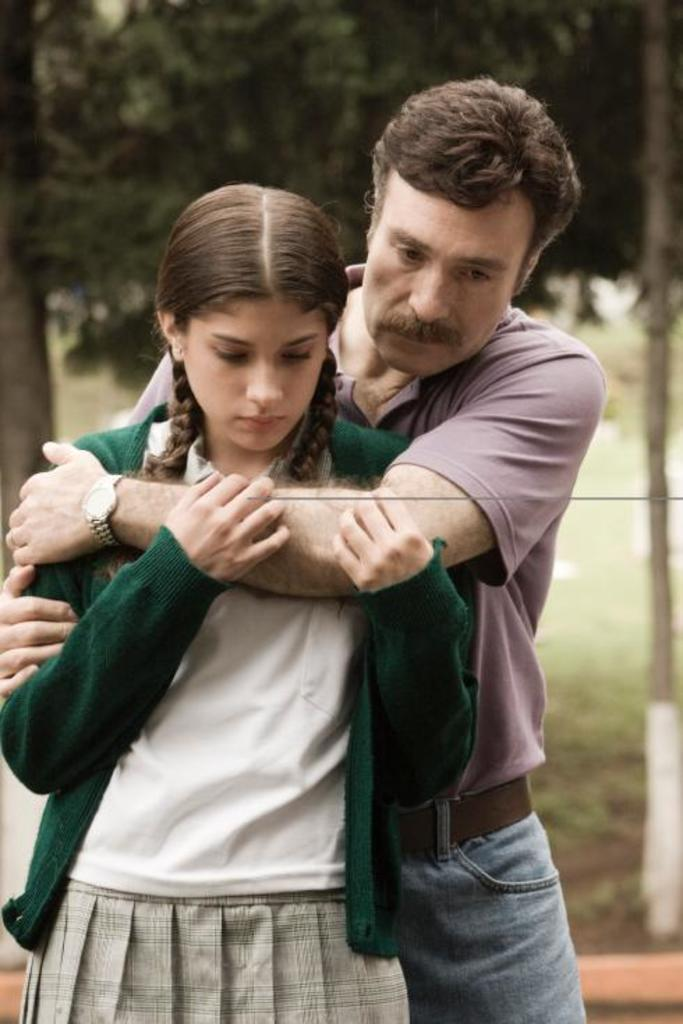Who is present in the image? There is a man and a girl in the image. What is the man doing with the girl? The man is holding the girl's shoulder. What is the girl doing with the man? The girl is holding the man's hand. What can be seen in the background of the image? There is a grass surface, a tree, and a pole in the background of the image. What type of farming equipment can be seen in the image? There is no farming equipment present in the image. How does the girl rub the man's hand in the image? The girl is not rubbing the man's hand in the image; she is simply holding it. 